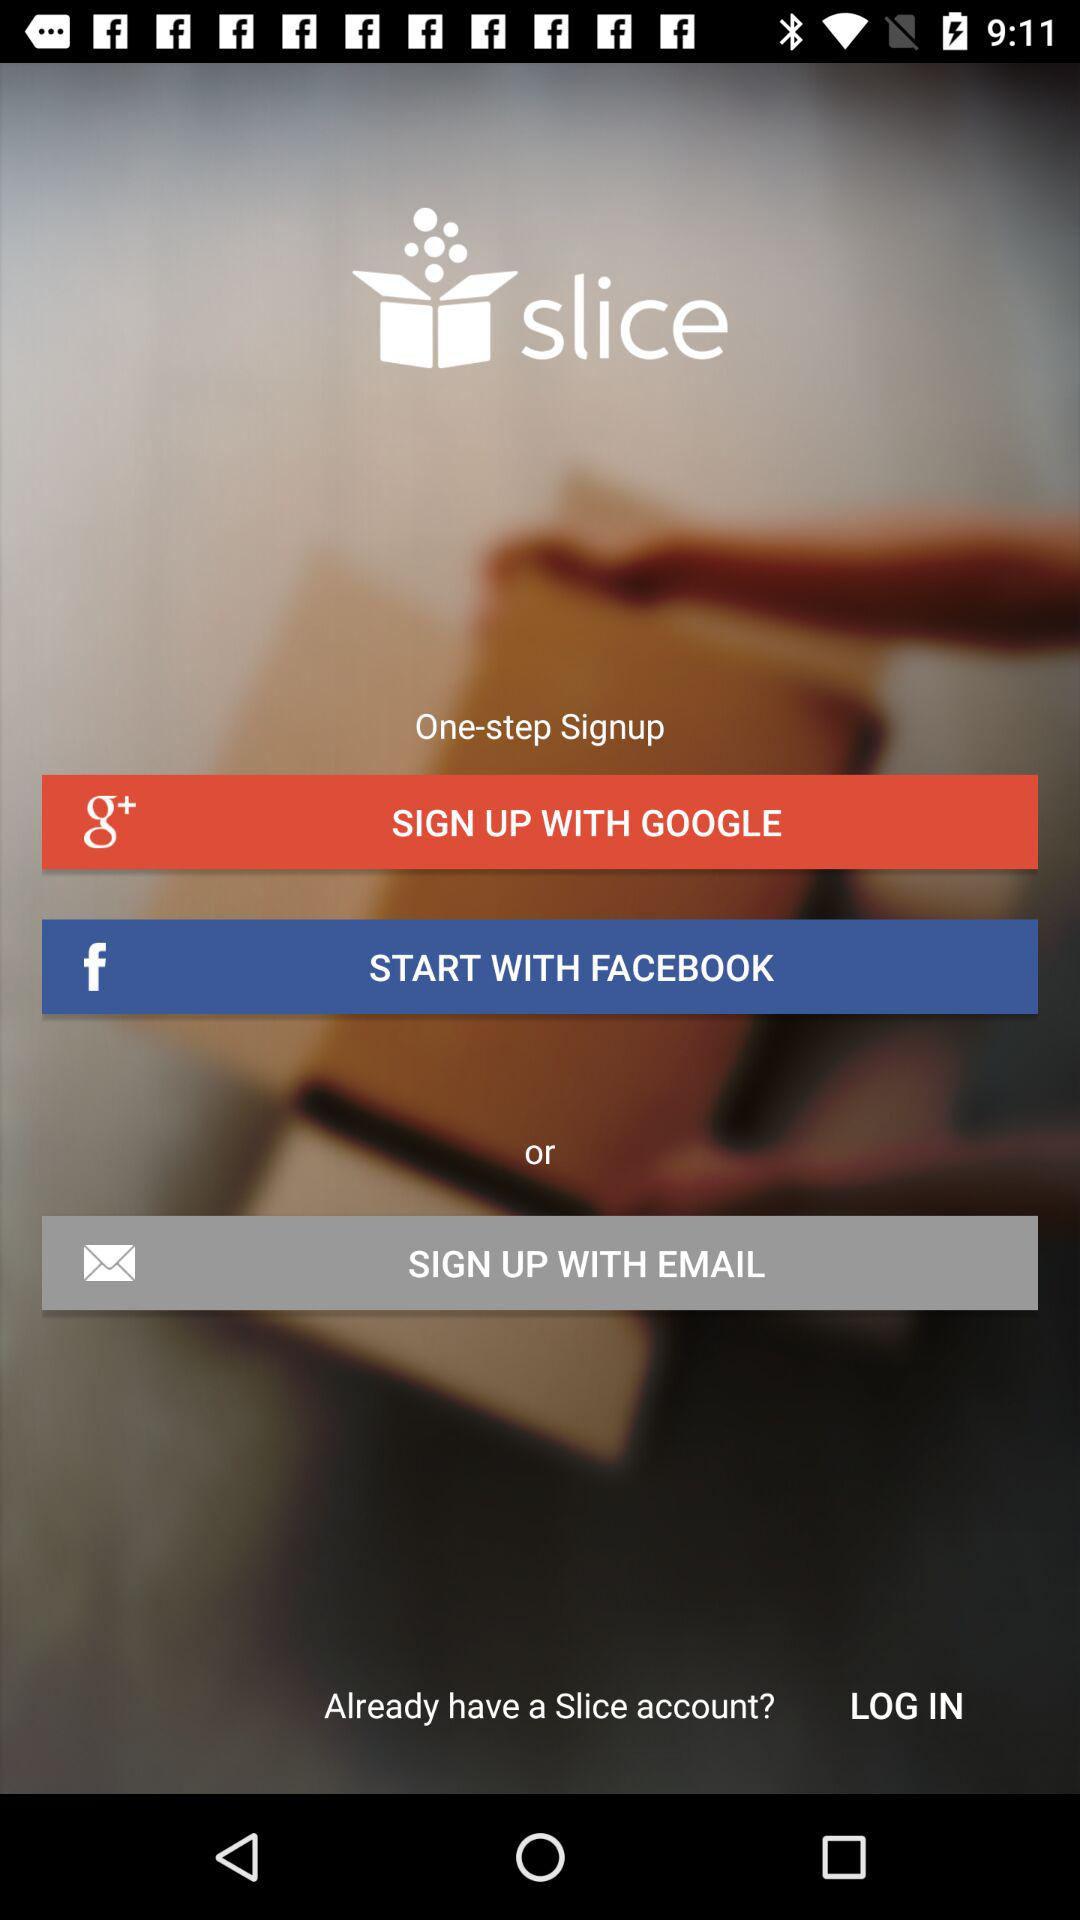What's the number of steps for sign-up? The number of steps for sign-up is 1. 